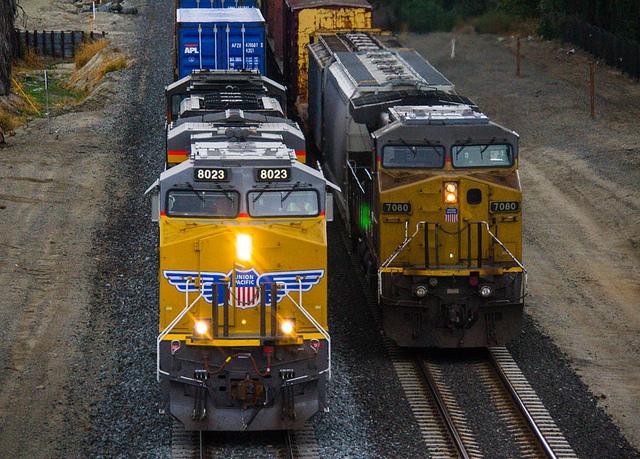Which train is ahead?
Write a very short answer. Left. What number is on the left train?
Short answer required. 8023. How many trains are shown?
Concise answer only. 2. 